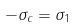<formula> <loc_0><loc_0><loc_500><loc_500>- \sigma _ { c } = \sigma _ { 1 }</formula> 